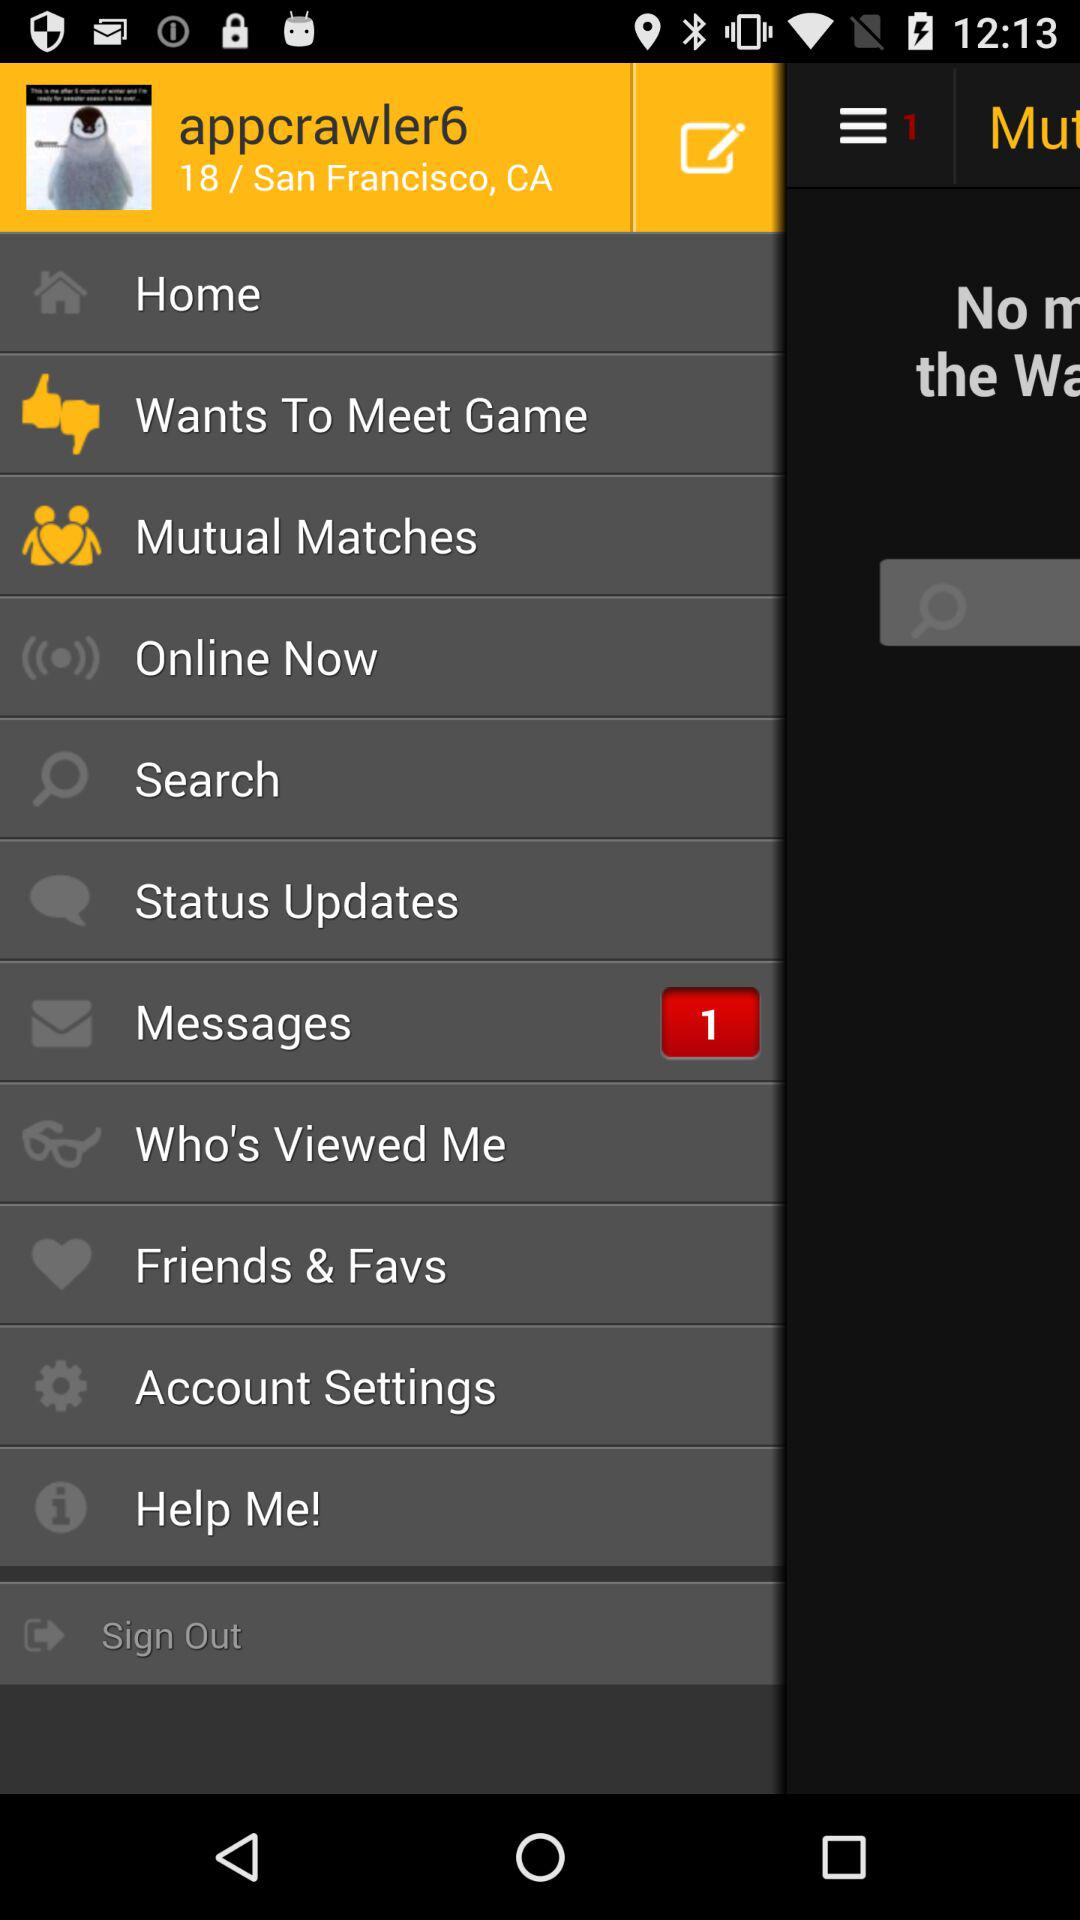How many notifications are there in "Account Settings"?
When the provided information is insufficient, respond with <no answer>. <no answer> 